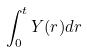Convert formula to latex. <formula><loc_0><loc_0><loc_500><loc_500>\int _ { 0 } ^ { t } Y ( r ) d r</formula> 